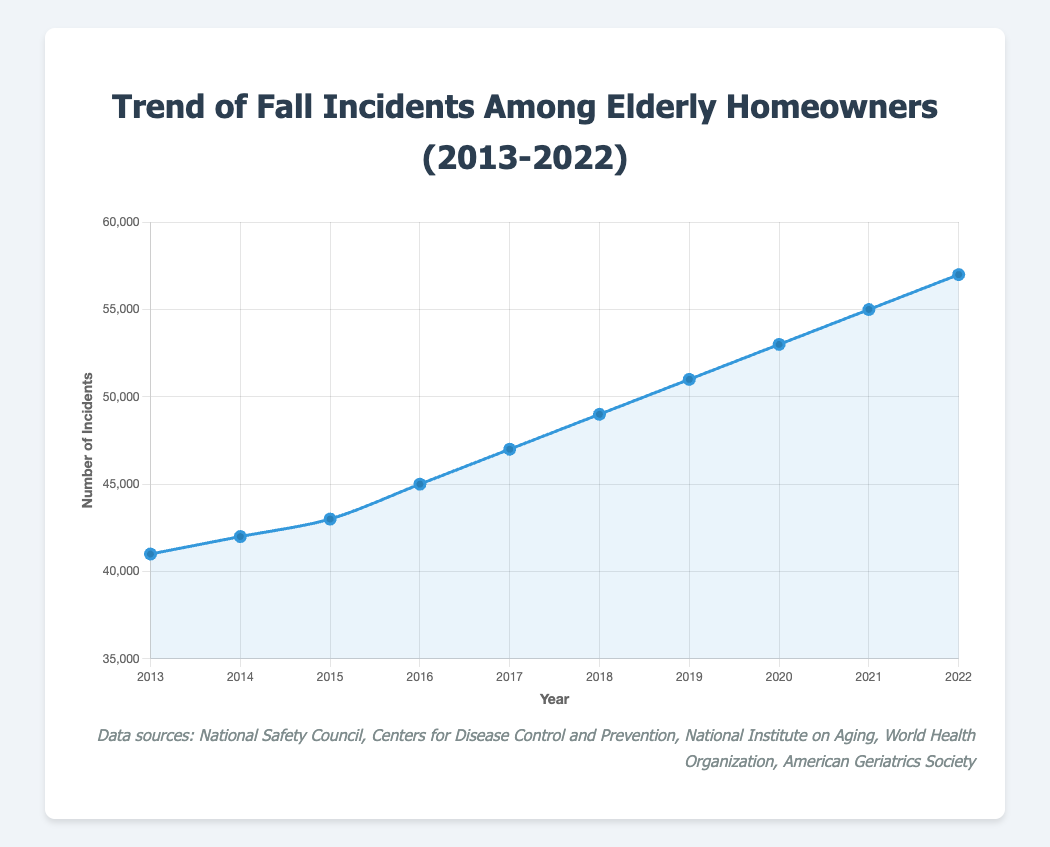What's the total number of fall incidents reported from 2013 to 2022? Sum the number of incidents for each year: 41000 (2013) + 42000 (2014) + 43000 (2015) + 45000 (2016) + 47000 (2017) + 49000 (2018) + 51000 (2019) + 53000 (2020) + 55000 (2021) + 57000 (2022). This equals 483000.
Answer: 483000 Which year experienced the highest number of fall incidents? Look for the tallest point on the line chart. The highest number of incidents is at 57000 in 2022.
Answer: 2022 How many more fall incidents were there in 2022 compared to 2013? Subtract the number of incidents in 2013 (41000) from the number in 2022 (57000): 57000 - 41000 = 16000.
Answer: 16000 What is the average number of fall incidents per year over the reported period? Calculate the average by dividing the total number of incidents (483000) by the number of years (10). 483000 / 10 = 48300.
Answer: 48300 What's the difference between the number of fall incidents in 2015 and 2019? Subtract the number of incidents in 2015 (43000) from the number in 2019 (51000): 51000 - 43000 = 8000.
Answer: 8000 Between which consecutive years did the number of fall incidents increase the most? Calculate the differences between consecutive years: 
2014-2013: 1000;
2015-2014: 1000;
2016-2015: 2000;
2017-2016: 2000;
2018-2017: 2000;
2019-2018: 2000;
2020-2019: 2000;
2021-2020: 2000;
2022-2021: 2000.
The biggest increase is between any pairing from 2016 to 2017, as they show the same rise of 2000.
Answer: 2015-2022 How does the trend of fall incidents visually appear over the decade? The line chart shows an upward trend, indicating that the number of fall incidents has steadily increased over the years from 2013 to 2022.
Answer: Upward trend In which year did the number of fall incidents first exceed 50000? Identify the first point where the incidents are above 50000; this is in 2019 with 51000 incidents.
Answer: 2019 If the trend continues, what can be the projected number for fall incidents in 2023? The yearly increment has been roughly 2000 since 2016. Adding 2000 to the 2022 value (57000): 57000 + 2000 = 59000 incidents projected for 2023.
Answer: 59000 